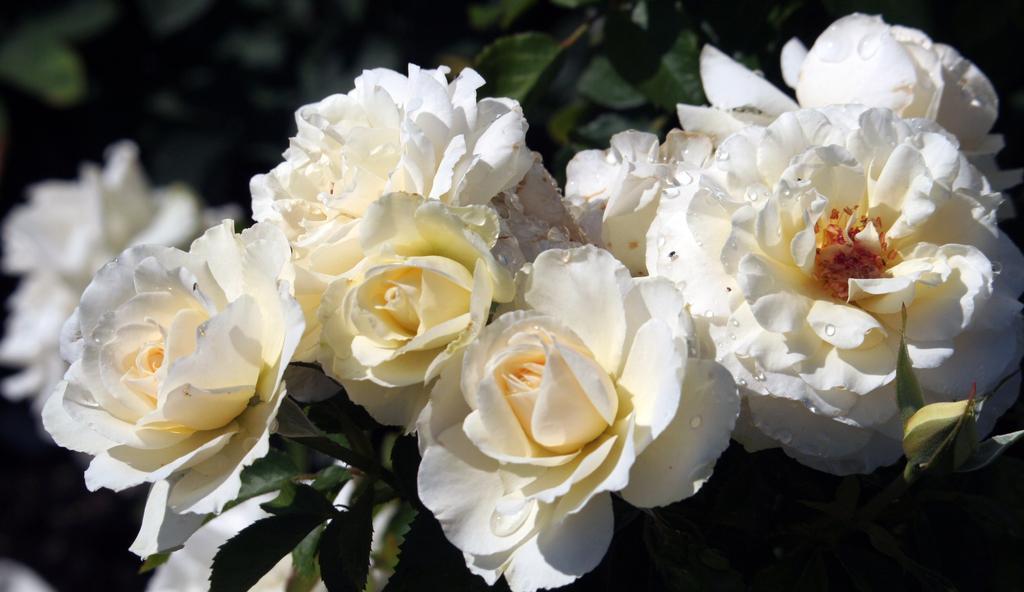How would you summarize this image in a sentence or two? In this picture we can see flowers, bud and leaves. In the background of the image it is blurry. 